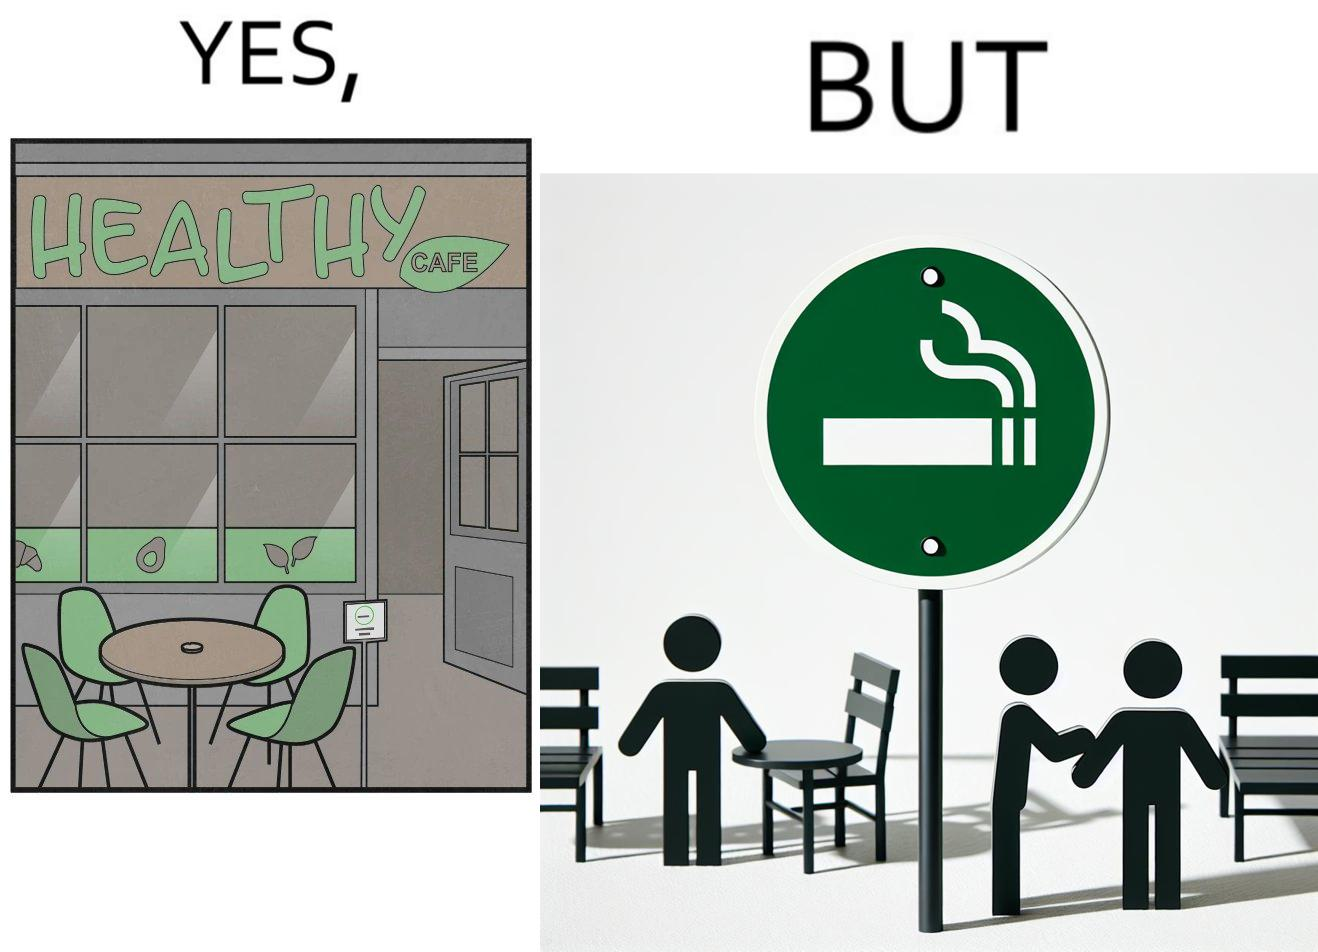Why is this image considered satirical? This image is funny because an eatery that calls itself the "healthy" cafe also has a smoking area, which is not very "healthy". If it really was a healthy cafe, it would not have a smoking area as smoking is injurious to health. Satire on the behavior of humans - both those that operate this cafe who made the decision of allowing smoking and creating a designated smoking area, and those that visit this healthy cafe to become "healthy", but then also indulge in very unhealthy habits simultaneously. 